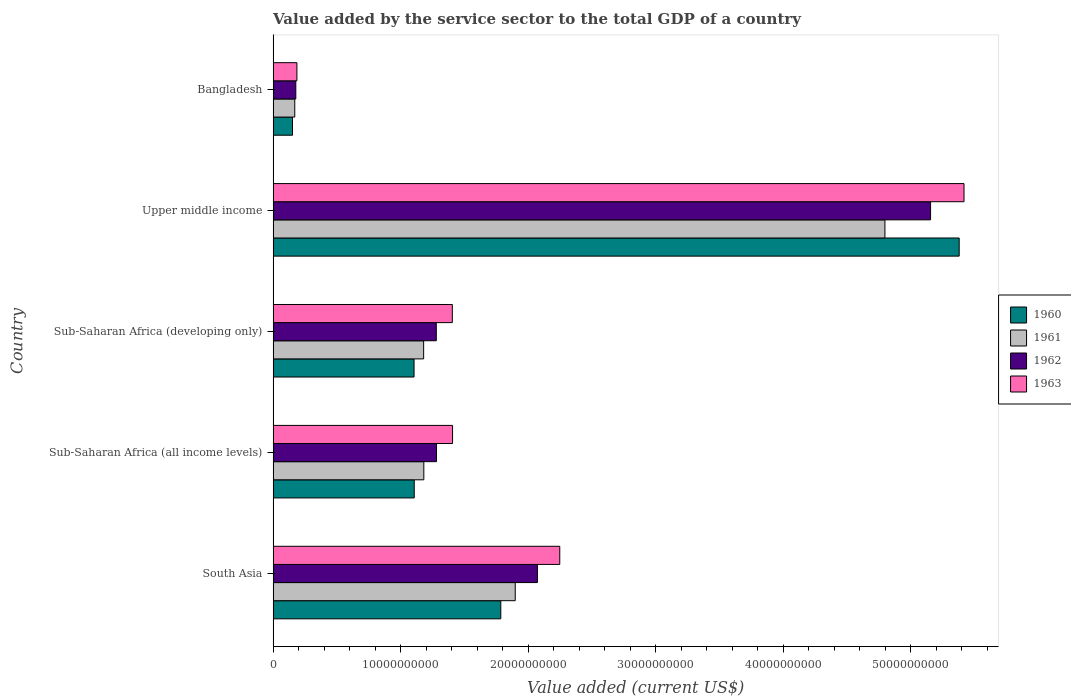How many different coloured bars are there?
Your answer should be compact. 4. How many groups of bars are there?
Keep it short and to the point. 5. Are the number of bars per tick equal to the number of legend labels?
Your answer should be compact. Yes. Are the number of bars on each tick of the Y-axis equal?
Give a very brief answer. Yes. How many bars are there on the 4th tick from the top?
Offer a very short reply. 4. How many bars are there on the 5th tick from the bottom?
Provide a short and direct response. 4. What is the label of the 4th group of bars from the top?
Provide a succinct answer. Sub-Saharan Africa (all income levels). What is the value added by the service sector to the total GDP in 1962 in Sub-Saharan Africa (developing only)?
Offer a very short reply. 1.28e+1. Across all countries, what is the maximum value added by the service sector to the total GDP in 1962?
Ensure brevity in your answer.  5.16e+1. Across all countries, what is the minimum value added by the service sector to the total GDP in 1961?
Your response must be concise. 1.70e+09. In which country was the value added by the service sector to the total GDP in 1960 maximum?
Your answer should be compact. Upper middle income. In which country was the value added by the service sector to the total GDP in 1963 minimum?
Offer a very short reply. Bangladesh. What is the total value added by the service sector to the total GDP in 1962 in the graph?
Make the answer very short. 9.97e+1. What is the difference between the value added by the service sector to the total GDP in 1960 in South Asia and that in Sub-Saharan Africa (all income levels)?
Give a very brief answer. 6.79e+09. What is the difference between the value added by the service sector to the total GDP in 1960 in Bangladesh and the value added by the service sector to the total GDP in 1962 in Upper middle income?
Give a very brief answer. -5.00e+1. What is the average value added by the service sector to the total GDP in 1960 per country?
Provide a short and direct response. 1.91e+1. What is the difference between the value added by the service sector to the total GDP in 1962 and value added by the service sector to the total GDP in 1963 in Sub-Saharan Africa (all income levels)?
Provide a short and direct response. -1.26e+09. In how many countries, is the value added by the service sector to the total GDP in 1961 greater than 14000000000 US$?
Offer a very short reply. 2. What is the ratio of the value added by the service sector to the total GDP in 1960 in Sub-Saharan Africa (all income levels) to that in Sub-Saharan Africa (developing only)?
Provide a succinct answer. 1. Is the value added by the service sector to the total GDP in 1963 in Sub-Saharan Africa (developing only) less than that in Upper middle income?
Keep it short and to the point. Yes. Is the difference between the value added by the service sector to the total GDP in 1962 in South Asia and Sub-Saharan Africa (developing only) greater than the difference between the value added by the service sector to the total GDP in 1963 in South Asia and Sub-Saharan Africa (developing only)?
Your answer should be very brief. No. What is the difference between the highest and the second highest value added by the service sector to the total GDP in 1961?
Provide a succinct answer. 2.90e+1. What is the difference between the highest and the lowest value added by the service sector to the total GDP in 1962?
Keep it short and to the point. 4.98e+1. In how many countries, is the value added by the service sector to the total GDP in 1962 greater than the average value added by the service sector to the total GDP in 1962 taken over all countries?
Your answer should be compact. 2. Is the sum of the value added by the service sector to the total GDP in 1963 in Bangladesh and Upper middle income greater than the maximum value added by the service sector to the total GDP in 1961 across all countries?
Make the answer very short. Yes. Is it the case that in every country, the sum of the value added by the service sector to the total GDP in 1960 and value added by the service sector to the total GDP in 1963 is greater than the sum of value added by the service sector to the total GDP in 1961 and value added by the service sector to the total GDP in 1962?
Offer a very short reply. No. What does the 1st bar from the top in South Asia represents?
Keep it short and to the point. 1963. How many countries are there in the graph?
Give a very brief answer. 5. What is the difference between two consecutive major ticks on the X-axis?
Offer a terse response. 1.00e+1. Are the values on the major ticks of X-axis written in scientific E-notation?
Keep it short and to the point. No. Does the graph contain grids?
Offer a terse response. No. Where does the legend appear in the graph?
Ensure brevity in your answer.  Center right. How many legend labels are there?
Keep it short and to the point. 4. How are the legend labels stacked?
Your answer should be compact. Vertical. What is the title of the graph?
Your answer should be compact. Value added by the service sector to the total GDP of a country. Does "1965" appear as one of the legend labels in the graph?
Offer a terse response. No. What is the label or title of the X-axis?
Make the answer very short. Value added (current US$). What is the Value added (current US$) of 1960 in South Asia?
Give a very brief answer. 1.79e+1. What is the Value added (current US$) of 1961 in South Asia?
Give a very brief answer. 1.90e+1. What is the Value added (current US$) in 1962 in South Asia?
Ensure brevity in your answer.  2.07e+1. What is the Value added (current US$) in 1963 in South Asia?
Provide a succinct answer. 2.25e+1. What is the Value added (current US$) of 1960 in Sub-Saharan Africa (all income levels)?
Ensure brevity in your answer.  1.11e+1. What is the Value added (current US$) in 1961 in Sub-Saharan Africa (all income levels)?
Provide a succinct answer. 1.18e+1. What is the Value added (current US$) of 1962 in Sub-Saharan Africa (all income levels)?
Your answer should be compact. 1.28e+1. What is the Value added (current US$) in 1963 in Sub-Saharan Africa (all income levels)?
Offer a terse response. 1.41e+1. What is the Value added (current US$) in 1960 in Sub-Saharan Africa (developing only)?
Give a very brief answer. 1.10e+1. What is the Value added (current US$) of 1961 in Sub-Saharan Africa (developing only)?
Offer a terse response. 1.18e+1. What is the Value added (current US$) of 1962 in Sub-Saharan Africa (developing only)?
Provide a short and direct response. 1.28e+1. What is the Value added (current US$) of 1963 in Sub-Saharan Africa (developing only)?
Make the answer very short. 1.41e+1. What is the Value added (current US$) of 1960 in Upper middle income?
Your answer should be very brief. 5.38e+1. What is the Value added (current US$) of 1961 in Upper middle income?
Provide a short and direct response. 4.80e+1. What is the Value added (current US$) in 1962 in Upper middle income?
Your answer should be very brief. 5.16e+1. What is the Value added (current US$) of 1963 in Upper middle income?
Offer a terse response. 5.42e+1. What is the Value added (current US$) in 1960 in Bangladesh?
Offer a terse response. 1.52e+09. What is the Value added (current US$) in 1961 in Bangladesh?
Your response must be concise. 1.70e+09. What is the Value added (current US$) in 1962 in Bangladesh?
Your answer should be compact. 1.78e+09. What is the Value added (current US$) of 1963 in Bangladesh?
Ensure brevity in your answer.  1.86e+09. Across all countries, what is the maximum Value added (current US$) of 1960?
Your answer should be compact. 5.38e+1. Across all countries, what is the maximum Value added (current US$) of 1961?
Offer a terse response. 4.80e+1. Across all countries, what is the maximum Value added (current US$) in 1962?
Make the answer very short. 5.16e+1. Across all countries, what is the maximum Value added (current US$) of 1963?
Your answer should be compact. 5.42e+1. Across all countries, what is the minimum Value added (current US$) in 1960?
Give a very brief answer. 1.52e+09. Across all countries, what is the minimum Value added (current US$) of 1961?
Offer a terse response. 1.70e+09. Across all countries, what is the minimum Value added (current US$) of 1962?
Your response must be concise. 1.78e+09. Across all countries, what is the minimum Value added (current US$) of 1963?
Give a very brief answer. 1.86e+09. What is the total Value added (current US$) in 1960 in the graph?
Your answer should be compact. 9.53e+1. What is the total Value added (current US$) of 1961 in the graph?
Offer a terse response. 9.23e+1. What is the total Value added (current US$) in 1962 in the graph?
Provide a succinct answer. 9.97e+1. What is the total Value added (current US$) of 1963 in the graph?
Keep it short and to the point. 1.07e+11. What is the difference between the Value added (current US$) in 1960 in South Asia and that in Sub-Saharan Africa (all income levels)?
Offer a terse response. 6.79e+09. What is the difference between the Value added (current US$) of 1961 in South Asia and that in Sub-Saharan Africa (all income levels)?
Provide a succinct answer. 7.17e+09. What is the difference between the Value added (current US$) of 1962 in South Asia and that in Sub-Saharan Africa (all income levels)?
Offer a very short reply. 7.91e+09. What is the difference between the Value added (current US$) in 1963 in South Asia and that in Sub-Saharan Africa (all income levels)?
Make the answer very short. 8.41e+09. What is the difference between the Value added (current US$) of 1960 in South Asia and that in Sub-Saharan Africa (developing only)?
Offer a very short reply. 6.80e+09. What is the difference between the Value added (current US$) in 1961 in South Asia and that in Sub-Saharan Africa (developing only)?
Offer a very short reply. 7.18e+09. What is the difference between the Value added (current US$) of 1962 in South Asia and that in Sub-Saharan Africa (developing only)?
Give a very brief answer. 7.93e+09. What is the difference between the Value added (current US$) of 1963 in South Asia and that in Sub-Saharan Africa (developing only)?
Your answer should be compact. 8.42e+09. What is the difference between the Value added (current US$) of 1960 in South Asia and that in Upper middle income?
Give a very brief answer. -3.59e+1. What is the difference between the Value added (current US$) in 1961 in South Asia and that in Upper middle income?
Provide a short and direct response. -2.90e+1. What is the difference between the Value added (current US$) in 1962 in South Asia and that in Upper middle income?
Give a very brief answer. -3.08e+1. What is the difference between the Value added (current US$) in 1963 in South Asia and that in Upper middle income?
Keep it short and to the point. -3.17e+1. What is the difference between the Value added (current US$) in 1960 in South Asia and that in Bangladesh?
Your response must be concise. 1.63e+1. What is the difference between the Value added (current US$) of 1961 in South Asia and that in Bangladesh?
Keep it short and to the point. 1.73e+1. What is the difference between the Value added (current US$) in 1962 in South Asia and that in Bangladesh?
Offer a terse response. 1.89e+1. What is the difference between the Value added (current US$) in 1963 in South Asia and that in Bangladesh?
Your answer should be compact. 2.06e+1. What is the difference between the Value added (current US$) of 1960 in Sub-Saharan Africa (all income levels) and that in Sub-Saharan Africa (developing only)?
Make the answer very short. 1.42e+07. What is the difference between the Value added (current US$) of 1961 in Sub-Saharan Africa (all income levels) and that in Sub-Saharan Africa (developing only)?
Ensure brevity in your answer.  1.52e+07. What is the difference between the Value added (current US$) in 1962 in Sub-Saharan Africa (all income levels) and that in Sub-Saharan Africa (developing only)?
Offer a terse response. 1.65e+07. What is the difference between the Value added (current US$) in 1963 in Sub-Saharan Africa (all income levels) and that in Sub-Saharan Africa (developing only)?
Your response must be concise. 1.81e+07. What is the difference between the Value added (current US$) in 1960 in Sub-Saharan Africa (all income levels) and that in Upper middle income?
Keep it short and to the point. -4.27e+1. What is the difference between the Value added (current US$) in 1961 in Sub-Saharan Africa (all income levels) and that in Upper middle income?
Provide a short and direct response. -3.62e+1. What is the difference between the Value added (current US$) in 1962 in Sub-Saharan Africa (all income levels) and that in Upper middle income?
Give a very brief answer. -3.87e+1. What is the difference between the Value added (current US$) in 1963 in Sub-Saharan Africa (all income levels) and that in Upper middle income?
Give a very brief answer. -4.01e+1. What is the difference between the Value added (current US$) in 1960 in Sub-Saharan Africa (all income levels) and that in Bangladesh?
Offer a terse response. 9.54e+09. What is the difference between the Value added (current US$) in 1961 in Sub-Saharan Africa (all income levels) and that in Bangladesh?
Keep it short and to the point. 1.01e+1. What is the difference between the Value added (current US$) of 1962 in Sub-Saharan Africa (all income levels) and that in Bangladesh?
Ensure brevity in your answer.  1.10e+1. What is the difference between the Value added (current US$) of 1963 in Sub-Saharan Africa (all income levels) and that in Bangladesh?
Offer a very short reply. 1.22e+1. What is the difference between the Value added (current US$) in 1960 in Sub-Saharan Africa (developing only) and that in Upper middle income?
Provide a short and direct response. -4.27e+1. What is the difference between the Value added (current US$) in 1961 in Sub-Saharan Africa (developing only) and that in Upper middle income?
Keep it short and to the point. -3.62e+1. What is the difference between the Value added (current US$) in 1962 in Sub-Saharan Africa (developing only) and that in Upper middle income?
Provide a short and direct response. -3.88e+1. What is the difference between the Value added (current US$) in 1963 in Sub-Saharan Africa (developing only) and that in Upper middle income?
Your response must be concise. -4.01e+1. What is the difference between the Value added (current US$) in 1960 in Sub-Saharan Africa (developing only) and that in Bangladesh?
Offer a very short reply. 9.53e+09. What is the difference between the Value added (current US$) of 1961 in Sub-Saharan Africa (developing only) and that in Bangladesh?
Offer a very short reply. 1.01e+1. What is the difference between the Value added (current US$) of 1962 in Sub-Saharan Africa (developing only) and that in Bangladesh?
Your answer should be very brief. 1.10e+1. What is the difference between the Value added (current US$) of 1963 in Sub-Saharan Africa (developing only) and that in Bangladesh?
Ensure brevity in your answer.  1.22e+1. What is the difference between the Value added (current US$) of 1960 in Upper middle income and that in Bangladesh?
Keep it short and to the point. 5.23e+1. What is the difference between the Value added (current US$) of 1961 in Upper middle income and that in Bangladesh?
Your answer should be very brief. 4.63e+1. What is the difference between the Value added (current US$) in 1962 in Upper middle income and that in Bangladesh?
Make the answer very short. 4.98e+1. What is the difference between the Value added (current US$) in 1963 in Upper middle income and that in Bangladesh?
Offer a very short reply. 5.23e+1. What is the difference between the Value added (current US$) in 1960 in South Asia and the Value added (current US$) in 1961 in Sub-Saharan Africa (all income levels)?
Provide a short and direct response. 6.03e+09. What is the difference between the Value added (current US$) in 1960 in South Asia and the Value added (current US$) in 1962 in Sub-Saharan Africa (all income levels)?
Your response must be concise. 5.04e+09. What is the difference between the Value added (current US$) of 1960 in South Asia and the Value added (current US$) of 1963 in Sub-Saharan Africa (all income levels)?
Offer a terse response. 3.78e+09. What is the difference between the Value added (current US$) of 1961 in South Asia and the Value added (current US$) of 1962 in Sub-Saharan Africa (all income levels)?
Your answer should be compact. 6.17e+09. What is the difference between the Value added (current US$) in 1961 in South Asia and the Value added (current US$) in 1963 in Sub-Saharan Africa (all income levels)?
Your answer should be very brief. 4.91e+09. What is the difference between the Value added (current US$) in 1962 in South Asia and the Value added (current US$) in 1963 in Sub-Saharan Africa (all income levels)?
Your answer should be compact. 6.65e+09. What is the difference between the Value added (current US$) in 1960 in South Asia and the Value added (current US$) in 1961 in Sub-Saharan Africa (developing only)?
Offer a very short reply. 6.05e+09. What is the difference between the Value added (current US$) in 1960 in South Asia and the Value added (current US$) in 1962 in Sub-Saharan Africa (developing only)?
Your answer should be very brief. 5.06e+09. What is the difference between the Value added (current US$) of 1960 in South Asia and the Value added (current US$) of 1963 in Sub-Saharan Africa (developing only)?
Your answer should be very brief. 3.80e+09. What is the difference between the Value added (current US$) of 1961 in South Asia and the Value added (current US$) of 1962 in Sub-Saharan Africa (developing only)?
Your answer should be very brief. 6.19e+09. What is the difference between the Value added (current US$) in 1961 in South Asia and the Value added (current US$) in 1963 in Sub-Saharan Africa (developing only)?
Provide a short and direct response. 4.93e+09. What is the difference between the Value added (current US$) of 1962 in South Asia and the Value added (current US$) of 1963 in Sub-Saharan Africa (developing only)?
Provide a short and direct response. 6.67e+09. What is the difference between the Value added (current US$) of 1960 in South Asia and the Value added (current US$) of 1961 in Upper middle income?
Your answer should be compact. -3.01e+1. What is the difference between the Value added (current US$) in 1960 in South Asia and the Value added (current US$) in 1962 in Upper middle income?
Offer a terse response. -3.37e+1. What is the difference between the Value added (current US$) in 1960 in South Asia and the Value added (current US$) in 1963 in Upper middle income?
Offer a terse response. -3.63e+1. What is the difference between the Value added (current US$) of 1961 in South Asia and the Value added (current US$) of 1962 in Upper middle income?
Your response must be concise. -3.26e+1. What is the difference between the Value added (current US$) of 1961 in South Asia and the Value added (current US$) of 1963 in Upper middle income?
Keep it short and to the point. -3.52e+1. What is the difference between the Value added (current US$) in 1962 in South Asia and the Value added (current US$) in 1963 in Upper middle income?
Provide a succinct answer. -3.34e+1. What is the difference between the Value added (current US$) in 1960 in South Asia and the Value added (current US$) in 1961 in Bangladesh?
Your answer should be compact. 1.62e+1. What is the difference between the Value added (current US$) of 1960 in South Asia and the Value added (current US$) of 1962 in Bangladesh?
Provide a short and direct response. 1.61e+1. What is the difference between the Value added (current US$) in 1960 in South Asia and the Value added (current US$) in 1963 in Bangladesh?
Your response must be concise. 1.60e+1. What is the difference between the Value added (current US$) in 1961 in South Asia and the Value added (current US$) in 1962 in Bangladesh?
Provide a short and direct response. 1.72e+1. What is the difference between the Value added (current US$) in 1961 in South Asia and the Value added (current US$) in 1963 in Bangladesh?
Offer a very short reply. 1.71e+1. What is the difference between the Value added (current US$) in 1962 in South Asia and the Value added (current US$) in 1963 in Bangladesh?
Offer a terse response. 1.89e+1. What is the difference between the Value added (current US$) of 1960 in Sub-Saharan Africa (all income levels) and the Value added (current US$) of 1961 in Sub-Saharan Africa (developing only)?
Give a very brief answer. -7.38e+08. What is the difference between the Value added (current US$) of 1960 in Sub-Saharan Africa (all income levels) and the Value added (current US$) of 1962 in Sub-Saharan Africa (developing only)?
Provide a succinct answer. -1.73e+09. What is the difference between the Value added (current US$) of 1960 in Sub-Saharan Africa (all income levels) and the Value added (current US$) of 1963 in Sub-Saharan Africa (developing only)?
Your answer should be very brief. -2.99e+09. What is the difference between the Value added (current US$) in 1961 in Sub-Saharan Africa (all income levels) and the Value added (current US$) in 1962 in Sub-Saharan Africa (developing only)?
Offer a terse response. -9.78e+08. What is the difference between the Value added (current US$) of 1961 in Sub-Saharan Africa (all income levels) and the Value added (current US$) of 1963 in Sub-Saharan Africa (developing only)?
Provide a succinct answer. -2.23e+09. What is the difference between the Value added (current US$) in 1962 in Sub-Saharan Africa (all income levels) and the Value added (current US$) in 1963 in Sub-Saharan Africa (developing only)?
Keep it short and to the point. -1.24e+09. What is the difference between the Value added (current US$) in 1960 in Sub-Saharan Africa (all income levels) and the Value added (current US$) in 1961 in Upper middle income?
Ensure brevity in your answer.  -3.69e+1. What is the difference between the Value added (current US$) in 1960 in Sub-Saharan Africa (all income levels) and the Value added (current US$) in 1962 in Upper middle income?
Your response must be concise. -4.05e+1. What is the difference between the Value added (current US$) of 1960 in Sub-Saharan Africa (all income levels) and the Value added (current US$) of 1963 in Upper middle income?
Your answer should be very brief. -4.31e+1. What is the difference between the Value added (current US$) of 1961 in Sub-Saharan Africa (all income levels) and the Value added (current US$) of 1962 in Upper middle income?
Your answer should be compact. -3.97e+1. What is the difference between the Value added (current US$) in 1961 in Sub-Saharan Africa (all income levels) and the Value added (current US$) in 1963 in Upper middle income?
Your answer should be very brief. -4.24e+1. What is the difference between the Value added (current US$) of 1962 in Sub-Saharan Africa (all income levels) and the Value added (current US$) of 1963 in Upper middle income?
Your answer should be compact. -4.14e+1. What is the difference between the Value added (current US$) of 1960 in Sub-Saharan Africa (all income levels) and the Value added (current US$) of 1961 in Bangladesh?
Offer a very short reply. 9.37e+09. What is the difference between the Value added (current US$) in 1960 in Sub-Saharan Africa (all income levels) and the Value added (current US$) in 1962 in Bangladesh?
Ensure brevity in your answer.  9.28e+09. What is the difference between the Value added (current US$) in 1960 in Sub-Saharan Africa (all income levels) and the Value added (current US$) in 1963 in Bangladesh?
Your response must be concise. 9.20e+09. What is the difference between the Value added (current US$) of 1961 in Sub-Saharan Africa (all income levels) and the Value added (current US$) of 1962 in Bangladesh?
Provide a succinct answer. 1.00e+1. What is the difference between the Value added (current US$) of 1961 in Sub-Saharan Africa (all income levels) and the Value added (current US$) of 1963 in Bangladesh?
Offer a terse response. 9.95e+09. What is the difference between the Value added (current US$) in 1962 in Sub-Saharan Africa (all income levels) and the Value added (current US$) in 1963 in Bangladesh?
Offer a very short reply. 1.09e+1. What is the difference between the Value added (current US$) of 1960 in Sub-Saharan Africa (developing only) and the Value added (current US$) of 1961 in Upper middle income?
Your answer should be compact. -3.69e+1. What is the difference between the Value added (current US$) in 1960 in Sub-Saharan Africa (developing only) and the Value added (current US$) in 1962 in Upper middle income?
Provide a short and direct response. -4.05e+1. What is the difference between the Value added (current US$) in 1960 in Sub-Saharan Africa (developing only) and the Value added (current US$) in 1963 in Upper middle income?
Your answer should be compact. -4.31e+1. What is the difference between the Value added (current US$) in 1961 in Sub-Saharan Africa (developing only) and the Value added (current US$) in 1962 in Upper middle income?
Offer a terse response. -3.97e+1. What is the difference between the Value added (current US$) in 1961 in Sub-Saharan Africa (developing only) and the Value added (current US$) in 1963 in Upper middle income?
Offer a very short reply. -4.24e+1. What is the difference between the Value added (current US$) in 1962 in Sub-Saharan Africa (developing only) and the Value added (current US$) in 1963 in Upper middle income?
Your response must be concise. -4.14e+1. What is the difference between the Value added (current US$) in 1960 in Sub-Saharan Africa (developing only) and the Value added (current US$) in 1961 in Bangladesh?
Ensure brevity in your answer.  9.35e+09. What is the difference between the Value added (current US$) in 1960 in Sub-Saharan Africa (developing only) and the Value added (current US$) in 1962 in Bangladesh?
Keep it short and to the point. 9.27e+09. What is the difference between the Value added (current US$) in 1960 in Sub-Saharan Africa (developing only) and the Value added (current US$) in 1963 in Bangladesh?
Make the answer very short. 9.19e+09. What is the difference between the Value added (current US$) in 1961 in Sub-Saharan Africa (developing only) and the Value added (current US$) in 1962 in Bangladesh?
Keep it short and to the point. 1.00e+1. What is the difference between the Value added (current US$) in 1961 in Sub-Saharan Africa (developing only) and the Value added (current US$) in 1963 in Bangladesh?
Provide a succinct answer. 9.94e+09. What is the difference between the Value added (current US$) in 1962 in Sub-Saharan Africa (developing only) and the Value added (current US$) in 1963 in Bangladesh?
Offer a very short reply. 1.09e+1. What is the difference between the Value added (current US$) of 1960 in Upper middle income and the Value added (current US$) of 1961 in Bangladesh?
Offer a terse response. 5.21e+1. What is the difference between the Value added (current US$) of 1960 in Upper middle income and the Value added (current US$) of 1962 in Bangladesh?
Make the answer very short. 5.20e+1. What is the difference between the Value added (current US$) in 1960 in Upper middle income and the Value added (current US$) in 1963 in Bangladesh?
Offer a terse response. 5.19e+1. What is the difference between the Value added (current US$) of 1961 in Upper middle income and the Value added (current US$) of 1962 in Bangladesh?
Provide a succinct answer. 4.62e+1. What is the difference between the Value added (current US$) in 1961 in Upper middle income and the Value added (current US$) in 1963 in Bangladesh?
Make the answer very short. 4.61e+1. What is the difference between the Value added (current US$) in 1962 in Upper middle income and the Value added (current US$) in 1963 in Bangladesh?
Your answer should be very brief. 4.97e+1. What is the average Value added (current US$) in 1960 per country?
Offer a very short reply. 1.91e+1. What is the average Value added (current US$) of 1961 per country?
Ensure brevity in your answer.  1.85e+1. What is the average Value added (current US$) in 1962 per country?
Provide a short and direct response. 1.99e+1. What is the average Value added (current US$) of 1963 per country?
Provide a short and direct response. 2.13e+1. What is the difference between the Value added (current US$) in 1960 and Value added (current US$) in 1961 in South Asia?
Offer a terse response. -1.13e+09. What is the difference between the Value added (current US$) of 1960 and Value added (current US$) of 1962 in South Asia?
Your answer should be very brief. -2.87e+09. What is the difference between the Value added (current US$) of 1960 and Value added (current US$) of 1963 in South Asia?
Make the answer very short. -4.62e+09. What is the difference between the Value added (current US$) in 1961 and Value added (current US$) in 1962 in South Asia?
Provide a succinct answer. -1.74e+09. What is the difference between the Value added (current US$) in 1961 and Value added (current US$) in 1963 in South Asia?
Offer a terse response. -3.49e+09. What is the difference between the Value added (current US$) in 1962 and Value added (current US$) in 1963 in South Asia?
Make the answer very short. -1.75e+09. What is the difference between the Value added (current US$) in 1960 and Value added (current US$) in 1961 in Sub-Saharan Africa (all income levels)?
Your answer should be very brief. -7.53e+08. What is the difference between the Value added (current US$) in 1960 and Value added (current US$) in 1962 in Sub-Saharan Africa (all income levels)?
Give a very brief answer. -1.75e+09. What is the difference between the Value added (current US$) of 1960 and Value added (current US$) of 1963 in Sub-Saharan Africa (all income levels)?
Your answer should be very brief. -3.01e+09. What is the difference between the Value added (current US$) of 1961 and Value added (current US$) of 1962 in Sub-Saharan Africa (all income levels)?
Give a very brief answer. -9.94e+08. What is the difference between the Value added (current US$) in 1961 and Value added (current US$) in 1963 in Sub-Saharan Africa (all income levels)?
Offer a very short reply. -2.25e+09. What is the difference between the Value added (current US$) of 1962 and Value added (current US$) of 1963 in Sub-Saharan Africa (all income levels)?
Your answer should be very brief. -1.26e+09. What is the difference between the Value added (current US$) of 1960 and Value added (current US$) of 1961 in Sub-Saharan Africa (developing only)?
Make the answer very short. -7.52e+08. What is the difference between the Value added (current US$) in 1960 and Value added (current US$) in 1962 in Sub-Saharan Africa (developing only)?
Your answer should be very brief. -1.75e+09. What is the difference between the Value added (current US$) of 1960 and Value added (current US$) of 1963 in Sub-Saharan Africa (developing only)?
Ensure brevity in your answer.  -3.00e+09. What is the difference between the Value added (current US$) in 1961 and Value added (current US$) in 1962 in Sub-Saharan Africa (developing only)?
Your response must be concise. -9.93e+08. What is the difference between the Value added (current US$) in 1961 and Value added (current US$) in 1963 in Sub-Saharan Africa (developing only)?
Ensure brevity in your answer.  -2.25e+09. What is the difference between the Value added (current US$) of 1962 and Value added (current US$) of 1963 in Sub-Saharan Africa (developing only)?
Provide a short and direct response. -1.26e+09. What is the difference between the Value added (current US$) in 1960 and Value added (current US$) in 1961 in Upper middle income?
Give a very brief answer. 5.82e+09. What is the difference between the Value added (current US$) of 1960 and Value added (current US$) of 1962 in Upper middle income?
Offer a terse response. 2.24e+09. What is the difference between the Value added (current US$) in 1960 and Value added (current US$) in 1963 in Upper middle income?
Your answer should be compact. -3.78e+08. What is the difference between the Value added (current US$) of 1961 and Value added (current US$) of 1962 in Upper middle income?
Make the answer very short. -3.58e+09. What is the difference between the Value added (current US$) in 1961 and Value added (current US$) in 1963 in Upper middle income?
Provide a short and direct response. -6.20e+09. What is the difference between the Value added (current US$) of 1962 and Value added (current US$) of 1963 in Upper middle income?
Keep it short and to the point. -2.62e+09. What is the difference between the Value added (current US$) in 1960 and Value added (current US$) in 1961 in Bangladesh?
Your response must be concise. -1.77e+08. What is the difference between the Value added (current US$) of 1960 and Value added (current US$) of 1962 in Bangladesh?
Make the answer very short. -2.60e+08. What is the difference between the Value added (current US$) in 1960 and Value added (current US$) in 1963 in Bangladesh?
Ensure brevity in your answer.  -3.45e+08. What is the difference between the Value added (current US$) in 1961 and Value added (current US$) in 1962 in Bangladesh?
Make the answer very short. -8.27e+07. What is the difference between the Value added (current US$) in 1961 and Value added (current US$) in 1963 in Bangladesh?
Ensure brevity in your answer.  -1.68e+08. What is the difference between the Value added (current US$) in 1962 and Value added (current US$) in 1963 in Bangladesh?
Make the answer very short. -8.50e+07. What is the ratio of the Value added (current US$) of 1960 in South Asia to that in Sub-Saharan Africa (all income levels)?
Keep it short and to the point. 1.61. What is the ratio of the Value added (current US$) of 1961 in South Asia to that in Sub-Saharan Africa (all income levels)?
Offer a terse response. 1.61. What is the ratio of the Value added (current US$) of 1962 in South Asia to that in Sub-Saharan Africa (all income levels)?
Ensure brevity in your answer.  1.62. What is the ratio of the Value added (current US$) of 1963 in South Asia to that in Sub-Saharan Africa (all income levels)?
Provide a short and direct response. 1.6. What is the ratio of the Value added (current US$) in 1960 in South Asia to that in Sub-Saharan Africa (developing only)?
Your answer should be very brief. 1.62. What is the ratio of the Value added (current US$) of 1961 in South Asia to that in Sub-Saharan Africa (developing only)?
Make the answer very short. 1.61. What is the ratio of the Value added (current US$) in 1962 in South Asia to that in Sub-Saharan Africa (developing only)?
Offer a terse response. 1.62. What is the ratio of the Value added (current US$) of 1963 in South Asia to that in Sub-Saharan Africa (developing only)?
Your response must be concise. 1.6. What is the ratio of the Value added (current US$) of 1960 in South Asia to that in Upper middle income?
Your answer should be very brief. 0.33. What is the ratio of the Value added (current US$) in 1961 in South Asia to that in Upper middle income?
Keep it short and to the point. 0.4. What is the ratio of the Value added (current US$) of 1962 in South Asia to that in Upper middle income?
Give a very brief answer. 0.4. What is the ratio of the Value added (current US$) in 1963 in South Asia to that in Upper middle income?
Offer a very short reply. 0.41. What is the ratio of the Value added (current US$) in 1960 in South Asia to that in Bangladesh?
Provide a short and direct response. 11.75. What is the ratio of the Value added (current US$) in 1961 in South Asia to that in Bangladesh?
Offer a very short reply. 11.19. What is the ratio of the Value added (current US$) in 1962 in South Asia to that in Bangladesh?
Ensure brevity in your answer.  11.65. What is the ratio of the Value added (current US$) of 1963 in South Asia to that in Bangladesh?
Ensure brevity in your answer.  12.06. What is the ratio of the Value added (current US$) of 1961 in Sub-Saharan Africa (all income levels) to that in Sub-Saharan Africa (developing only)?
Provide a short and direct response. 1. What is the ratio of the Value added (current US$) in 1962 in Sub-Saharan Africa (all income levels) to that in Sub-Saharan Africa (developing only)?
Your answer should be very brief. 1. What is the ratio of the Value added (current US$) in 1960 in Sub-Saharan Africa (all income levels) to that in Upper middle income?
Your answer should be very brief. 0.21. What is the ratio of the Value added (current US$) of 1961 in Sub-Saharan Africa (all income levels) to that in Upper middle income?
Offer a very short reply. 0.25. What is the ratio of the Value added (current US$) of 1962 in Sub-Saharan Africa (all income levels) to that in Upper middle income?
Your answer should be compact. 0.25. What is the ratio of the Value added (current US$) in 1963 in Sub-Saharan Africa (all income levels) to that in Upper middle income?
Offer a very short reply. 0.26. What is the ratio of the Value added (current US$) in 1960 in Sub-Saharan Africa (all income levels) to that in Bangladesh?
Offer a terse response. 7.28. What is the ratio of the Value added (current US$) in 1961 in Sub-Saharan Africa (all income levels) to that in Bangladesh?
Offer a very short reply. 6.96. What is the ratio of the Value added (current US$) in 1962 in Sub-Saharan Africa (all income levels) to that in Bangladesh?
Offer a terse response. 7.2. What is the ratio of the Value added (current US$) of 1963 in Sub-Saharan Africa (all income levels) to that in Bangladesh?
Offer a very short reply. 7.55. What is the ratio of the Value added (current US$) in 1960 in Sub-Saharan Africa (developing only) to that in Upper middle income?
Offer a very short reply. 0.21. What is the ratio of the Value added (current US$) of 1961 in Sub-Saharan Africa (developing only) to that in Upper middle income?
Keep it short and to the point. 0.25. What is the ratio of the Value added (current US$) in 1962 in Sub-Saharan Africa (developing only) to that in Upper middle income?
Keep it short and to the point. 0.25. What is the ratio of the Value added (current US$) in 1963 in Sub-Saharan Africa (developing only) to that in Upper middle income?
Offer a terse response. 0.26. What is the ratio of the Value added (current US$) of 1960 in Sub-Saharan Africa (developing only) to that in Bangladesh?
Make the answer very short. 7.27. What is the ratio of the Value added (current US$) of 1961 in Sub-Saharan Africa (developing only) to that in Bangladesh?
Offer a terse response. 6.96. What is the ratio of the Value added (current US$) of 1962 in Sub-Saharan Africa (developing only) to that in Bangladesh?
Give a very brief answer. 7.19. What is the ratio of the Value added (current US$) of 1963 in Sub-Saharan Africa (developing only) to that in Bangladesh?
Give a very brief answer. 7.54. What is the ratio of the Value added (current US$) of 1960 in Upper middle income to that in Bangladesh?
Offer a very short reply. 35.4. What is the ratio of the Value added (current US$) of 1961 in Upper middle income to that in Bangladesh?
Keep it short and to the point. 28.27. What is the ratio of the Value added (current US$) of 1962 in Upper middle income to that in Bangladesh?
Your answer should be very brief. 28.97. What is the ratio of the Value added (current US$) of 1963 in Upper middle income to that in Bangladesh?
Keep it short and to the point. 29.06. What is the difference between the highest and the second highest Value added (current US$) of 1960?
Give a very brief answer. 3.59e+1. What is the difference between the highest and the second highest Value added (current US$) in 1961?
Ensure brevity in your answer.  2.90e+1. What is the difference between the highest and the second highest Value added (current US$) of 1962?
Provide a short and direct response. 3.08e+1. What is the difference between the highest and the second highest Value added (current US$) of 1963?
Your answer should be very brief. 3.17e+1. What is the difference between the highest and the lowest Value added (current US$) in 1960?
Your response must be concise. 5.23e+1. What is the difference between the highest and the lowest Value added (current US$) of 1961?
Make the answer very short. 4.63e+1. What is the difference between the highest and the lowest Value added (current US$) of 1962?
Your answer should be compact. 4.98e+1. What is the difference between the highest and the lowest Value added (current US$) of 1963?
Your answer should be very brief. 5.23e+1. 